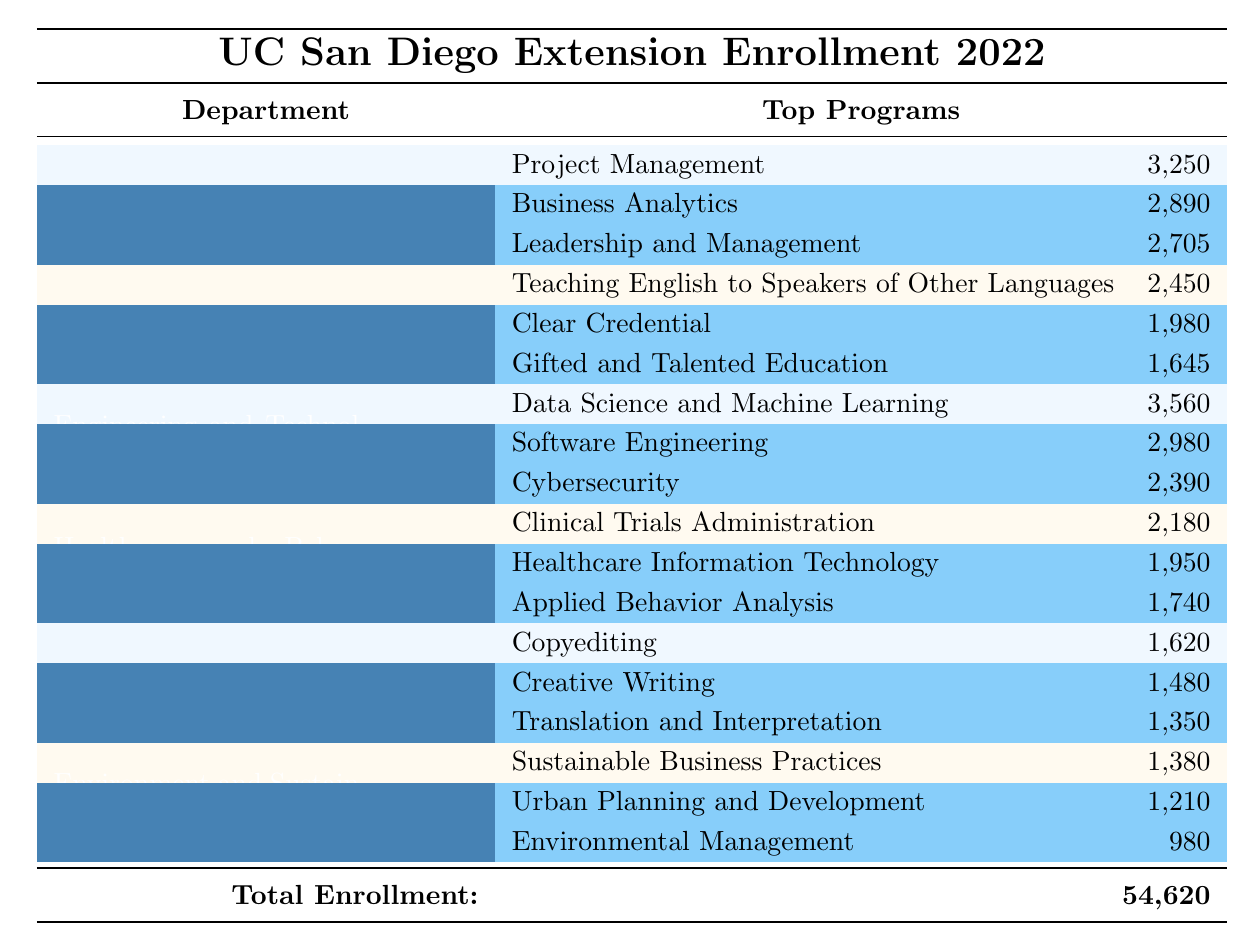What is the total enrollment for the University of California San Diego Extension program in 2022? The total enrollment value is explicitly stated at the bottom of the table as 54,620.
Answer: 54,620 Which department has the highest enrollment? By comparing the enrollment numbers listed beside each department, Engineering and Technology has the highest enrollment with 11,230 students.
Answer: Engineering and Technology How many students are enrolled in the Business Analytics program? The number of students enrolled in the Business Analytics program is provided in the sub-table under the Business and Leadership department, which shows 2,890 students.
Answer: 2,890 What is the total number of students enrolled in the Healthcare and Behavioral Sciences department? The total enrollment for the department is listed directly in the table as 8,970 students.
Answer: 8,970 Which program in the Education department has the most students? Among the programs listed under the Education department, Teaching English to Speakers of Other Languages has the highest enrollment with 2,450 students.
Answer: Teaching English to Speakers of Other Languages What percentage of the total enrollment does the Arts and Humanities department represent? The enrollment for the Arts and Humanities department is 6,850. To find its percentage of the total enrollment (54,620), calculate (6,850/54,620) * 100 ≈ 12.54%.
Answer: Approximately 12.54% How many more students are enrolled in Data Science and Machine Learning than in Cybersecurity? Data Science and Machine Learning has 3,560 students, and Cybersecurity has 2,390 students. The difference is 3,560 - 2,390 = 1,170.
Answer: 1,170 If the total enrollment of the Environment and Sustainability department increases by 10%, what will the new total be? The current enrollment for the Environment and Sustainability department is 4,850. If it increases by 10%, the increase would be 4,850 * 0.10 = 485. Thus, the new total will be 4,850 + 485 = 5,335.
Answer: 5,335 What is the combined total enrollment of the Business and Leadership and Engineering and Technology departments? Adding the enrollments for Business and Leadership (12,845) and Engineering and Technology (11,230) gives 12,845 + 11,230 = 24,075.
Answer: 24,075 Is there a program in the Environment and Sustainability department that has more than 1,000 students enrolled? Looking at the enrollment numbers for the programs in Environment and Sustainability, Sustainable Business Practices (1,380) and Urban Planning and Development (1,210) both exceed 1,000 students enrolled. Thus, the answer is yes.
Answer: Yes 